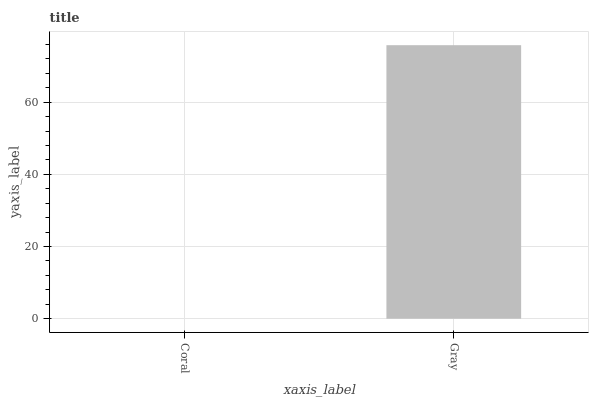Is Gray the minimum?
Answer yes or no. No. Is Gray greater than Coral?
Answer yes or no. Yes. Is Coral less than Gray?
Answer yes or no. Yes. Is Coral greater than Gray?
Answer yes or no. No. Is Gray less than Coral?
Answer yes or no. No. Is Gray the high median?
Answer yes or no. Yes. Is Coral the low median?
Answer yes or no. Yes. Is Coral the high median?
Answer yes or no. No. Is Gray the low median?
Answer yes or no. No. 